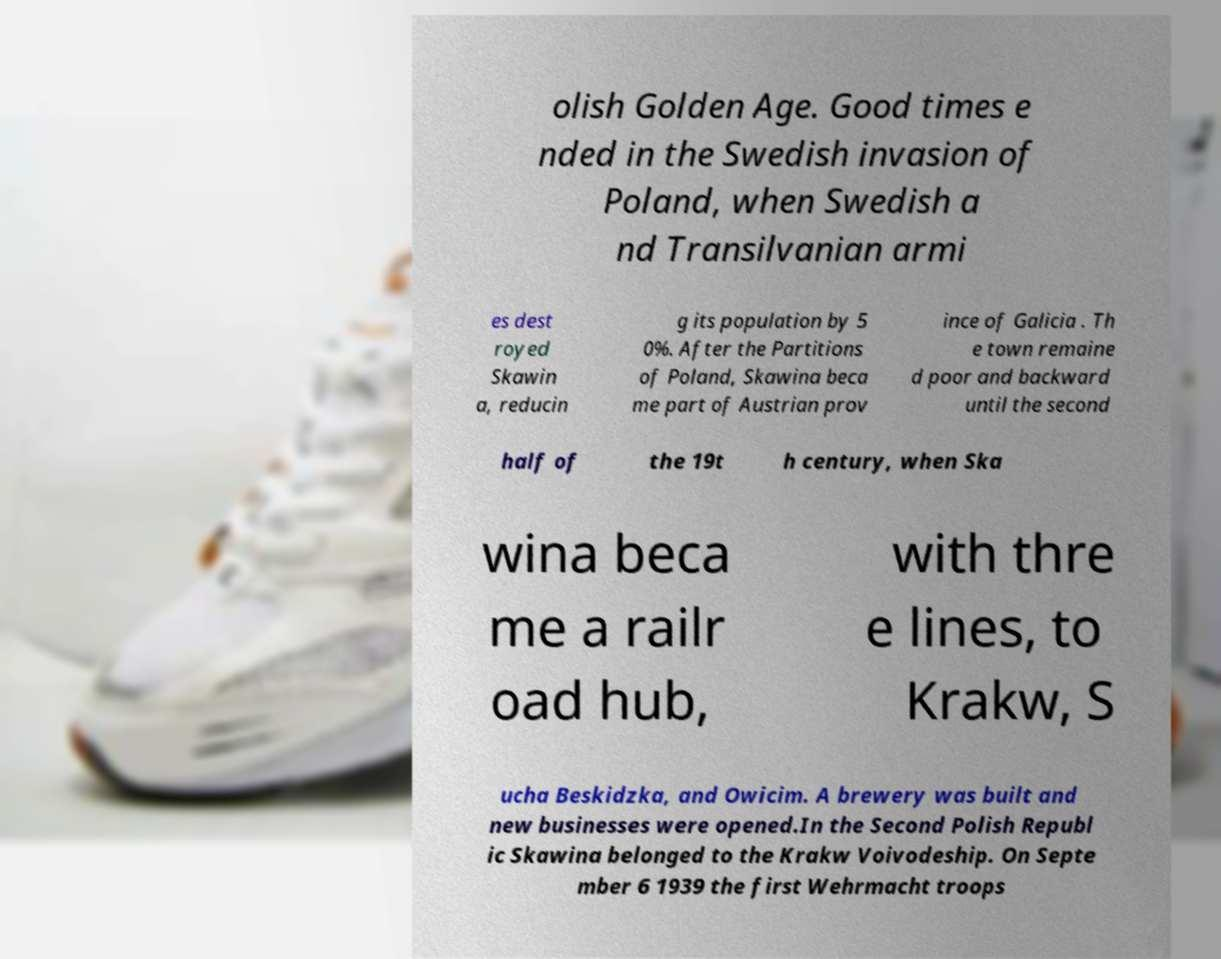Could you extract and type out the text from this image? olish Golden Age. Good times e nded in the Swedish invasion of Poland, when Swedish a nd Transilvanian armi es dest royed Skawin a, reducin g its population by 5 0%. After the Partitions of Poland, Skawina beca me part of Austrian prov ince of Galicia . Th e town remaine d poor and backward until the second half of the 19t h century, when Ska wina beca me a railr oad hub, with thre e lines, to Krakw, S ucha Beskidzka, and Owicim. A brewery was built and new businesses were opened.In the Second Polish Republ ic Skawina belonged to the Krakw Voivodeship. On Septe mber 6 1939 the first Wehrmacht troops 